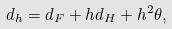<formula> <loc_0><loc_0><loc_500><loc_500>d _ { h } = d _ { F } + h d _ { H } + h ^ { 2 } \theta ,</formula> 